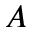Convert formula to latex. <formula><loc_0><loc_0><loc_500><loc_500>A</formula> 